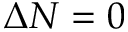<formula> <loc_0><loc_0><loc_500><loc_500>\Delta N = 0</formula> 